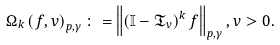Convert formula to latex. <formula><loc_0><loc_0><loc_500><loc_500>\Omega _ { k } \left ( f , v \right ) _ { p , \gamma } \colon = \left \| \left ( \mathbb { I } - \mathfrak { T } _ { v } \right ) ^ { k } f \right \| _ { p , \gamma } , v > 0 .</formula> 